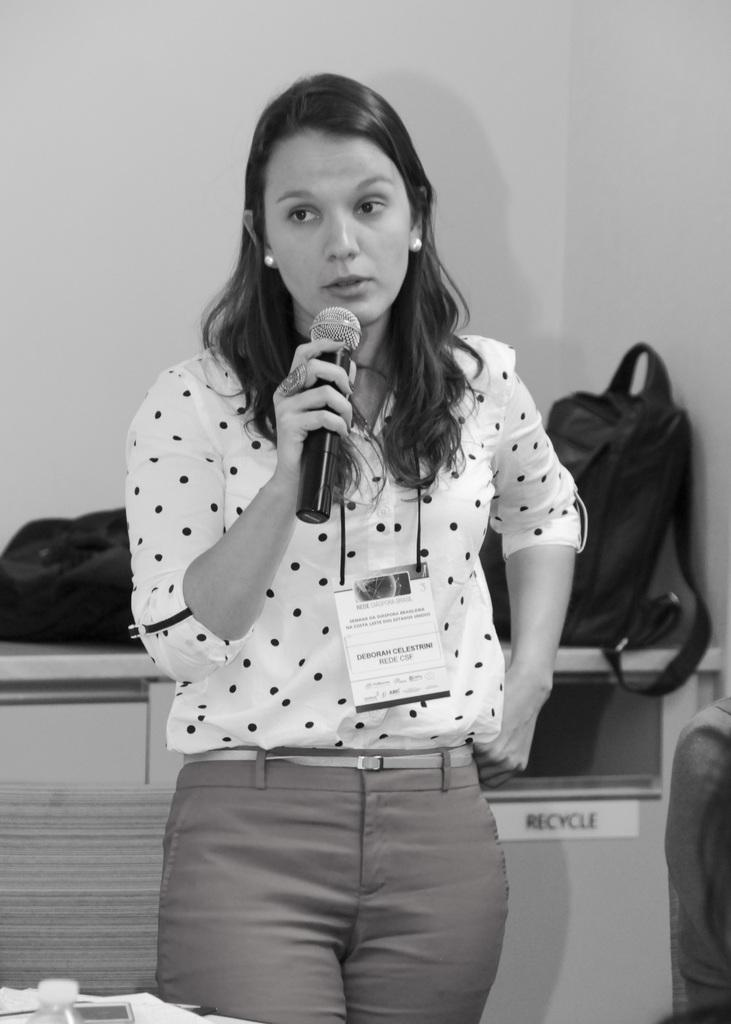Who or what is the main subject in the image? There is a person in the image. What is the person holding in the image? The person is holding a microphone. What can be seen in the background of the image? There are bags on a table in the background of the image. What type of news can be heard coming from the cows in the image? There are no cows present in the image, so it's not possible to determine what, if any, news might be heard from them. 